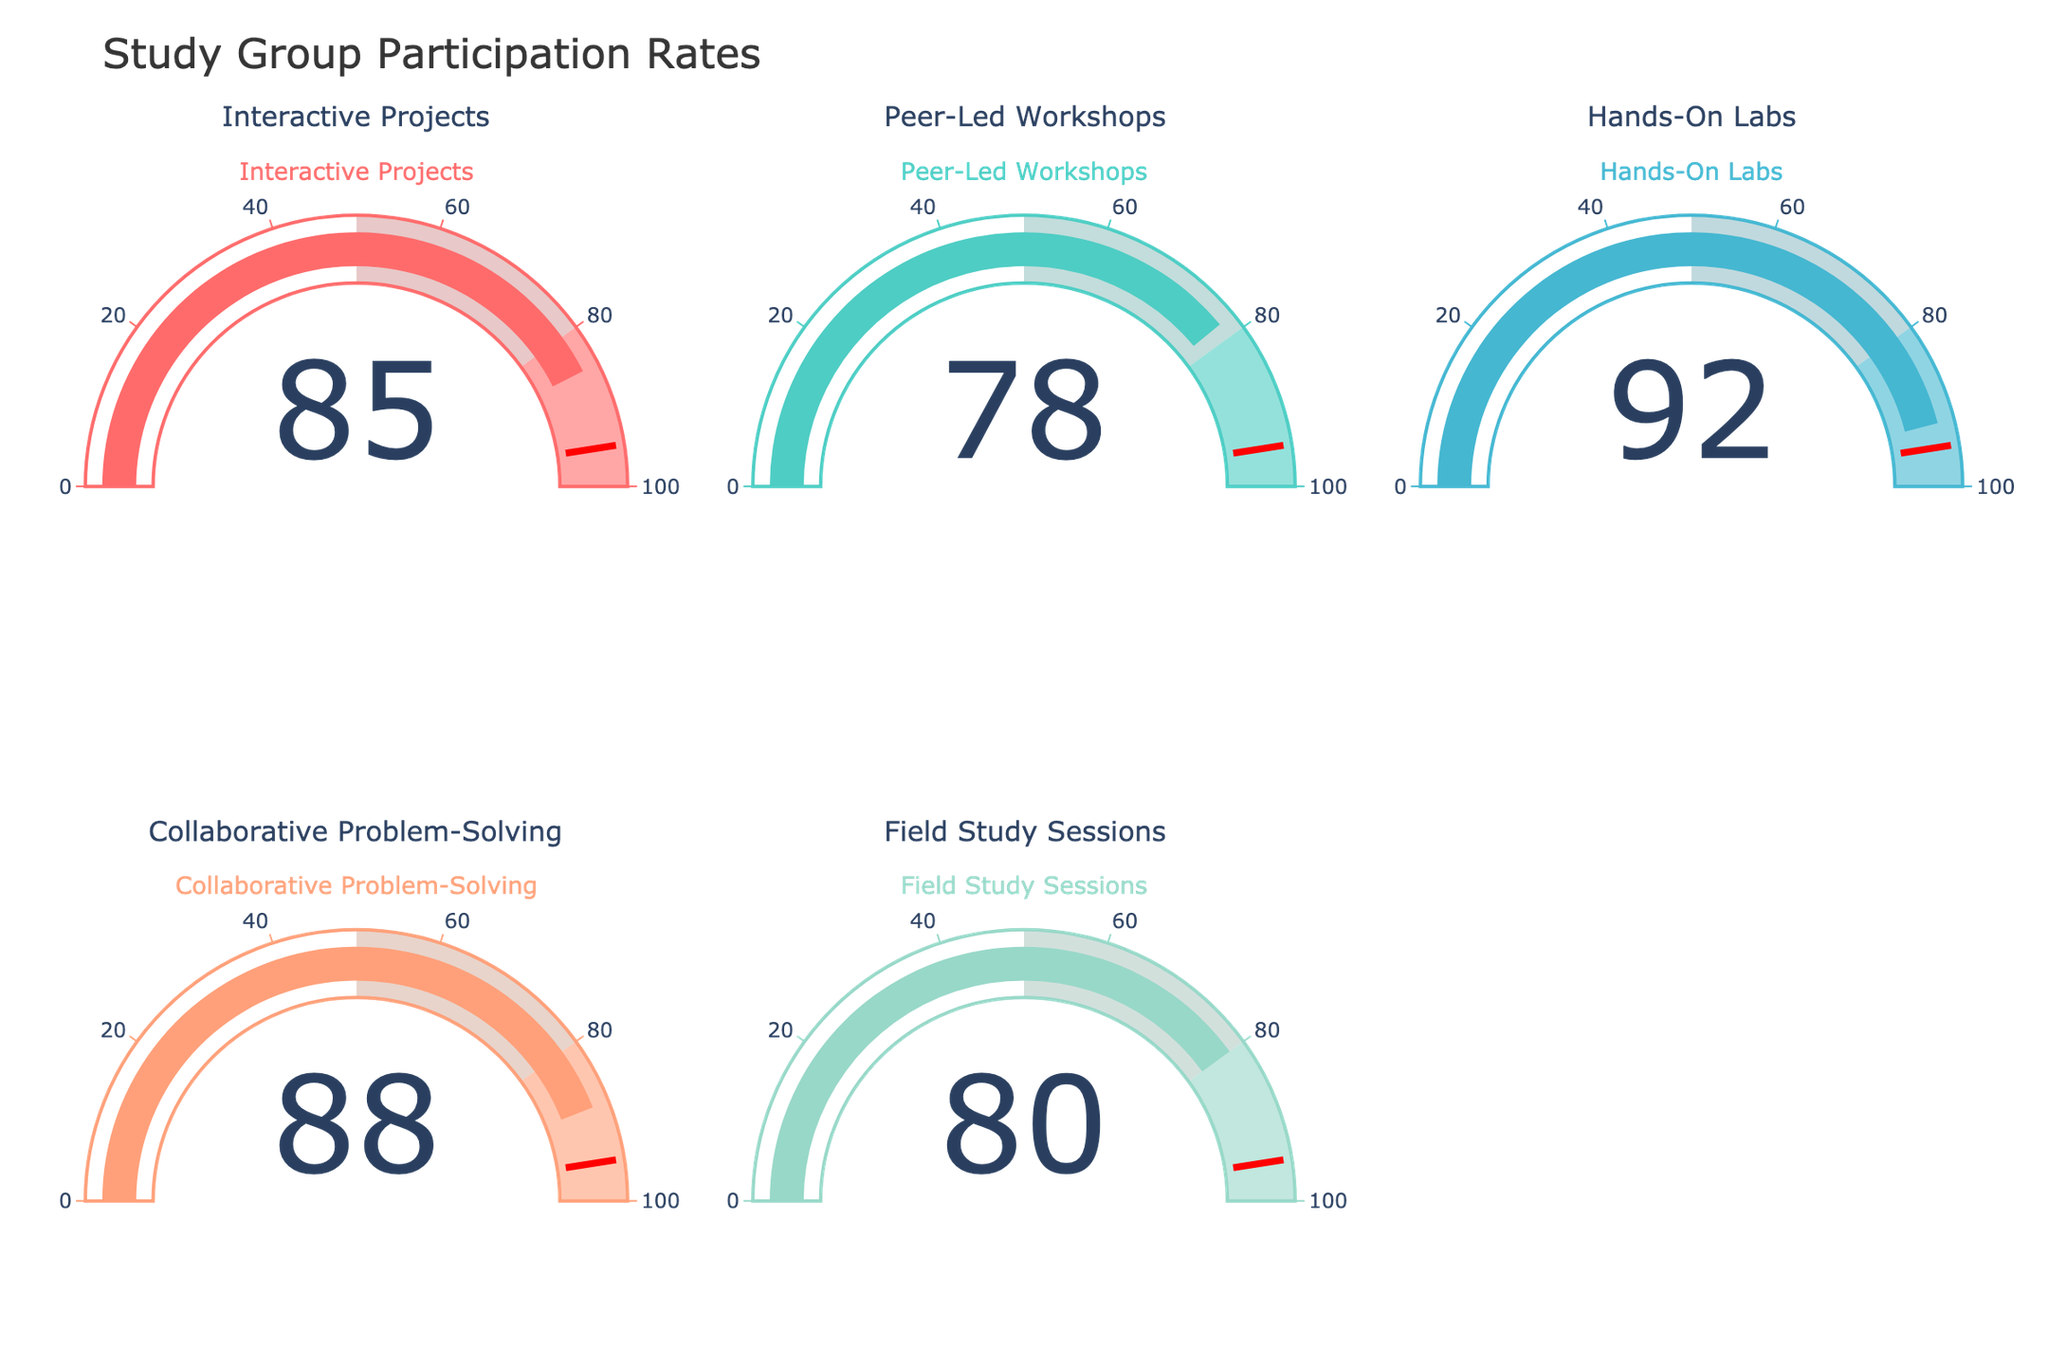Which study group has the highest participation rate? By looking at all the gauges, the Hands-On Labs group has the highest participation rate.
Answer: Hands-On Labs Which study group has the lowest participation rate? By examining the gauges, the Peer-Led Workshops group has the lowest participation rate.
Answer: Peer-Led Workshops What's the range of participation rates displayed in the figure? The highest rate is 92 for Hands-On Labs, and the lowest is 78 for Peer-Led Workshops. The range is 92 - 78 = 14.
Answer: 14 What is the average participation rate across all groups? Sum all participation rates (85, 78, 92, 88, 80) to get 423. Divide by the number of groups (5). The average is 423 / 5 = 84.6.
Answer: 84.6 Which group is closest to having an 85% participation rate? Look for the group with a participation rate closest to 85. The Interactive Projects group has exactly 85% participation.
Answer: Interactive Projects What's the difference in participation rates between Hands-On Labs and Field Study Sessions? Hands-On Labs has a participation rate of 92, and Field Study Sessions have a rate of 80. The difference is 92 - 80 = 12.
Answer: 12 Which group has a participation rate above 80% but below 90%? The Interactive Projects (85) and Collaborative Problem-Solving (88) groups fall within this range.
Answer: Interactive Projects, Collaborative Problem-Solving Is the participation rate for Peer-Led Workshops lower than Collaborative Problem-Solving by more than 10%? Peer-Led Workshops have a rate of 78% and Collaborative Problem-Solving has 88%. The difference is 88 - 78 = 10, which is exactly 10%.
Answer: No 